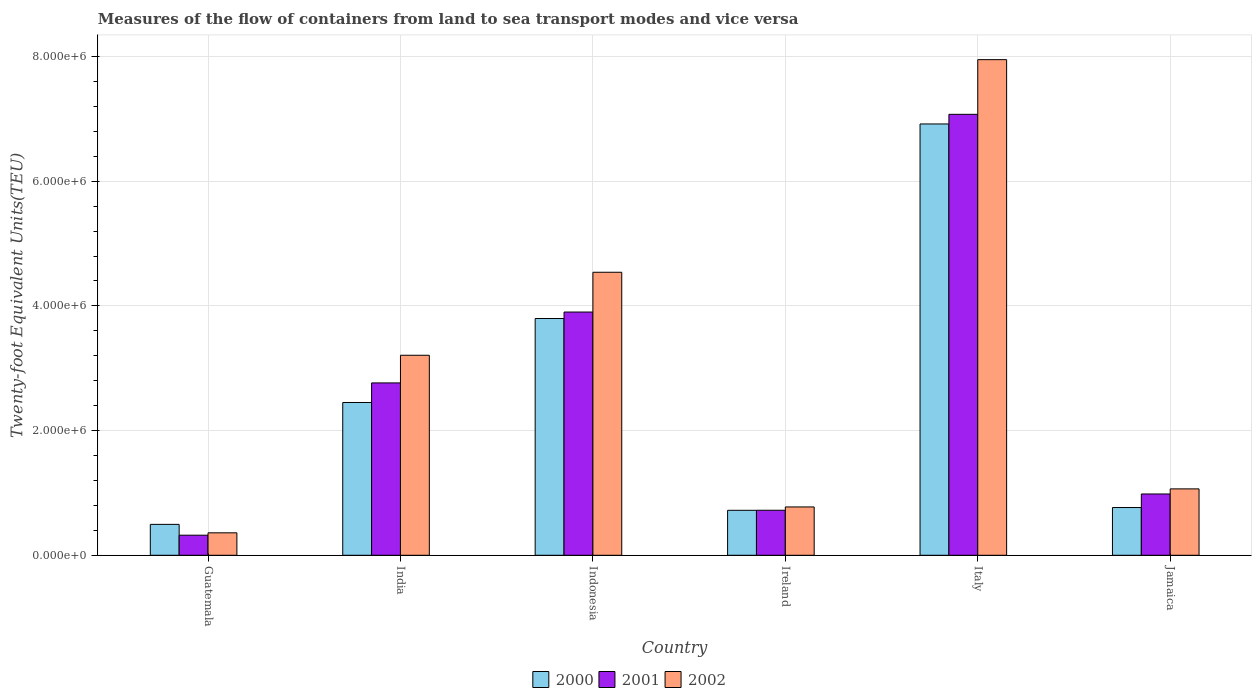Are the number of bars per tick equal to the number of legend labels?
Provide a short and direct response. Yes. Are the number of bars on each tick of the X-axis equal?
Offer a very short reply. Yes. How many bars are there on the 5th tick from the left?
Keep it short and to the point. 3. What is the label of the 3rd group of bars from the left?
Provide a short and direct response. Indonesia. What is the container port traffic in 2000 in Ireland?
Offer a terse response. 7.21e+05. Across all countries, what is the maximum container port traffic in 2001?
Offer a terse response. 7.07e+06. Across all countries, what is the minimum container port traffic in 2001?
Your answer should be very brief. 3.22e+05. In which country was the container port traffic in 2001 minimum?
Provide a short and direct response. Guatemala. What is the total container port traffic in 2001 in the graph?
Your answer should be very brief. 1.58e+07. What is the difference between the container port traffic in 2002 in India and that in Indonesia?
Your answer should be compact. -1.33e+06. What is the difference between the container port traffic in 2000 in Italy and the container port traffic in 2001 in India?
Keep it short and to the point. 4.15e+06. What is the average container port traffic in 2002 per country?
Provide a succinct answer. 2.98e+06. What is the difference between the container port traffic of/in 2001 and container port traffic of/in 2000 in Indonesia?
Your answer should be very brief. 1.04e+05. In how many countries, is the container port traffic in 2000 greater than 6400000 TEU?
Offer a terse response. 1. What is the ratio of the container port traffic in 2002 in Guatemala to that in Indonesia?
Your answer should be very brief. 0.08. What is the difference between the highest and the second highest container port traffic in 2002?
Ensure brevity in your answer.  -3.41e+06. What is the difference between the highest and the lowest container port traffic in 2001?
Provide a succinct answer. 6.75e+06. Is the sum of the container port traffic in 2001 in India and Italy greater than the maximum container port traffic in 2000 across all countries?
Make the answer very short. Yes. What does the 2nd bar from the right in Jamaica represents?
Keep it short and to the point. 2001. Are all the bars in the graph horizontal?
Ensure brevity in your answer.  No. What is the difference between two consecutive major ticks on the Y-axis?
Offer a very short reply. 2.00e+06. Does the graph contain grids?
Provide a short and direct response. Yes. What is the title of the graph?
Offer a terse response. Measures of the flow of containers from land to sea transport modes and vice versa. What is the label or title of the X-axis?
Give a very brief answer. Country. What is the label or title of the Y-axis?
Make the answer very short. Twenty-foot Equivalent Units(TEU). What is the Twenty-foot Equivalent Units(TEU) in 2000 in Guatemala?
Your answer should be compact. 4.96e+05. What is the Twenty-foot Equivalent Units(TEU) of 2001 in Guatemala?
Ensure brevity in your answer.  3.22e+05. What is the Twenty-foot Equivalent Units(TEU) of 2002 in Guatemala?
Provide a succinct answer. 3.60e+05. What is the Twenty-foot Equivalent Units(TEU) of 2000 in India?
Ensure brevity in your answer.  2.45e+06. What is the Twenty-foot Equivalent Units(TEU) of 2001 in India?
Ensure brevity in your answer.  2.76e+06. What is the Twenty-foot Equivalent Units(TEU) in 2002 in India?
Offer a terse response. 3.21e+06. What is the Twenty-foot Equivalent Units(TEU) in 2000 in Indonesia?
Ensure brevity in your answer.  3.80e+06. What is the Twenty-foot Equivalent Units(TEU) in 2001 in Indonesia?
Keep it short and to the point. 3.90e+06. What is the Twenty-foot Equivalent Units(TEU) in 2002 in Indonesia?
Provide a succinct answer. 4.54e+06. What is the Twenty-foot Equivalent Units(TEU) in 2000 in Ireland?
Your answer should be compact. 7.21e+05. What is the Twenty-foot Equivalent Units(TEU) of 2001 in Ireland?
Your answer should be very brief. 7.22e+05. What is the Twenty-foot Equivalent Units(TEU) of 2002 in Ireland?
Offer a terse response. 7.75e+05. What is the Twenty-foot Equivalent Units(TEU) in 2000 in Italy?
Offer a very short reply. 6.92e+06. What is the Twenty-foot Equivalent Units(TEU) in 2001 in Italy?
Offer a terse response. 7.07e+06. What is the Twenty-foot Equivalent Units(TEU) in 2002 in Italy?
Keep it short and to the point. 7.95e+06. What is the Twenty-foot Equivalent Units(TEU) of 2000 in Jamaica?
Ensure brevity in your answer.  7.66e+05. What is the Twenty-foot Equivalent Units(TEU) of 2001 in Jamaica?
Your answer should be compact. 9.83e+05. What is the Twenty-foot Equivalent Units(TEU) of 2002 in Jamaica?
Keep it short and to the point. 1.06e+06. Across all countries, what is the maximum Twenty-foot Equivalent Units(TEU) in 2000?
Keep it short and to the point. 6.92e+06. Across all countries, what is the maximum Twenty-foot Equivalent Units(TEU) in 2001?
Offer a very short reply. 7.07e+06. Across all countries, what is the maximum Twenty-foot Equivalent Units(TEU) of 2002?
Ensure brevity in your answer.  7.95e+06. Across all countries, what is the minimum Twenty-foot Equivalent Units(TEU) of 2000?
Your answer should be very brief. 4.96e+05. Across all countries, what is the minimum Twenty-foot Equivalent Units(TEU) in 2001?
Offer a terse response. 3.22e+05. Across all countries, what is the minimum Twenty-foot Equivalent Units(TEU) in 2002?
Your response must be concise. 3.60e+05. What is the total Twenty-foot Equivalent Units(TEU) of 2000 in the graph?
Provide a succinct answer. 1.52e+07. What is the total Twenty-foot Equivalent Units(TEU) in 2001 in the graph?
Keep it short and to the point. 1.58e+07. What is the total Twenty-foot Equivalent Units(TEU) in 2002 in the graph?
Provide a succinct answer. 1.79e+07. What is the difference between the Twenty-foot Equivalent Units(TEU) of 2000 in Guatemala and that in India?
Give a very brief answer. -1.95e+06. What is the difference between the Twenty-foot Equivalent Units(TEU) of 2001 in Guatemala and that in India?
Make the answer very short. -2.44e+06. What is the difference between the Twenty-foot Equivalent Units(TEU) of 2002 in Guatemala and that in India?
Make the answer very short. -2.85e+06. What is the difference between the Twenty-foot Equivalent Units(TEU) in 2000 in Guatemala and that in Indonesia?
Keep it short and to the point. -3.30e+06. What is the difference between the Twenty-foot Equivalent Units(TEU) in 2001 in Guatemala and that in Indonesia?
Ensure brevity in your answer.  -3.58e+06. What is the difference between the Twenty-foot Equivalent Units(TEU) in 2002 in Guatemala and that in Indonesia?
Make the answer very short. -4.18e+06. What is the difference between the Twenty-foot Equivalent Units(TEU) of 2000 in Guatemala and that in Ireland?
Provide a succinct answer. -2.26e+05. What is the difference between the Twenty-foot Equivalent Units(TEU) of 2001 in Guatemala and that in Ireland?
Your response must be concise. -4.00e+05. What is the difference between the Twenty-foot Equivalent Units(TEU) of 2002 in Guatemala and that in Ireland?
Give a very brief answer. -4.15e+05. What is the difference between the Twenty-foot Equivalent Units(TEU) in 2000 in Guatemala and that in Italy?
Give a very brief answer. -6.42e+06. What is the difference between the Twenty-foot Equivalent Units(TEU) of 2001 in Guatemala and that in Italy?
Ensure brevity in your answer.  -6.75e+06. What is the difference between the Twenty-foot Equivalent Units(TEU) of 2002 in Guatemala and that in Italy?
Your answer should be very brief. -7.59e+06. What is the difference between the Twenty-foot Equivalent Units(TEU) of 2000 in Guatemala and that in Jamaica?
Provide a short and direct response. -2.70e+05. What is the difference between the Twenty-foot Equivalent Units(TEU) of 2001 in Guatemala and that in Jamaica?
Make the answer very short. -6.61e+05. What is the difference between the Twenty-foot Equivalent Units(TEU) of 2002 in Guatemala and that in Jamaica?
Offer a terse response. -7.05e+05. What is the difference between the Twenty-foot Equivalent Units(TEU) in 2000 in India and that in Indonesia?
Provide a succinct answer. -1.35e+06. What is the difference between the Twenty-foot Equivalent Units(TEU) of 2001 in India and that in Indonesia?
Your answer should be very brief. -1.14e+06. What is the difference between the Twenty-foot Equivalent Units(TEU) in 2002 in India and that in Indonesia?
Give a very brief answer. -1.33e+06. What is the difference between the Twenty-foot Equivalent Units(TEU) of 2000 in India and that in Ireland?
Ensure brevity in your answer.  1.73e+06. What is the difference between the Twenty-foot Equivalent Units(TEU) of 2001 in India and that in Ireland?
Ensure brevity in your answer.  2.04e+06. What is the difference between the Twenty-foot Equivalent Units(TEU) in 2002 in India and that in Ireland?
Your answer should be very brief. 2.43e+06. What is the difference between the Twenty-foot Equivalent Units(TEU) in 2000 in India and that in Italy?
Your response must be concise. -4.47e+06. What is the difference between the Twenty-foot Equivalent Units(TEU) in 2001 in India and that in Italy?
Offer a terse response. -4.31e+06. What is the difference between the Twenty-foot Equivalent Units(TEU) of 2002 in India and that in Italy?
Offer a very short reply. -4.74e+06. What is the difference between the Twenty-foot Equivalent Units(TEU) in 2000 in India and that in Jamaica?
Your answer should be compact. 1.68e+06. What is the difference between the Twenty-foot Equivalent Units(TEU) of 2001 in India and that in Jamaica?
Your answer should be very brief. 1.78e+06. What is the difference between the Twenty-foot Equivalent Units(TEU) of 2002 in India and that in Jamaica?
Offer a terse response. 2.14e+06. What is the difference between the Twenty-foot Equivalent Units(TEU) in 2000 in Indonesia and that in Ireland?
Your answer should be very brief. 3.08e+06. What is the difference between the Twenty-foot Equivalent Units(TEU) in 2001 in Indonesia and that in Ireland?
Keep it short and to the point. 3.18e+06. What is the difference between the Twenty-foot Equivalent Units(TEU) in 2002 in Indonesia and that in Ireland?
Offer a terse response. 3.76e+06. What is the difference between the Twenty-foot Equivalent Units(TEU) in 2000 in Indonesia and that in Italy?
Provide a succinct answer. -3.12e+06. What is the difference between the Twenty-foot Equivalent Units(TEU) in 2001 in Indonesia and that in Italy?
Offer a terse response. -3.17e+06. What is the difference between the Twenty-foot Equivalent Units(TEU) of 2002 in Indonesia and that in Italy?
Your answer should be compact. -3.41e+06. What is the difference between the Twenty-foot Equivalent Units(TEU) of 2000 in Indonesia and that in Jamaica?
Your answer should be compact. 3.03e+06. What is the difference between the Twenty-foot Equivalent Units(TEU) in 2001 in Indonesia and that in Jamaica?
Make the answer very short. 2.92e+06. What is the difference between the Twenty-foot Equivalent Units(TEU) in 2002 in Indonesia and that in Jamaica?
Your answer should be very brief. 3.47e+06. What is the difference between the Twenty-foot Equivalent Units(TEU) of 2000 in Ireland and that in Italy?
Provide a succinct answer. -6.20e+06. What is the difference between the Twenty-foot Equivalent Units(TEU) in 2001 in Ireland and that in Italy?
Give a very brief answer. -6.35e+06. What is the difference between the Twenty-foot Equivalent Units(TEU) of 2002 in Ireland and that in Italy?
Your response must be concise. -7.17e+06. What is the difference between the Twenty-foot Equivalent Units(TEU) in 2000 in Ireland and that in Jamaica?
Provide a short and direct response. -4.46e+04. What is the difference between the Twenty-foot Equivalent Units(TEU) of 2001 in Ireland and that in Jamaica?
Your response must be concise. -2.61e+05. What is the difference between the Twenty-foot Equivalent Units(TEU) of 2002 in Ireland and that in Jamaica?
Give a very brief answer. -2.90e+05. What is the difference between the Twenty-foot Equivalent Units(TEU) of 2000 in Italy and that in Jamaica?
Offer a terse response. 6.15e+06. What is the difference between the Twenty-foot Equivalent Units(TEU) in 2001 in Italy and that in Jamaica?
Your answer should be compact. 6.09e+06. What is the difference between the Twenty-foot Equivalent Units(TEU) in 2002 in Italy and that in Jamaica?
Give a very brief answer. 6.89e+06. What is the difference between the Twenty-foot Equivalent Units(TEU) of 2000 in Guatemala and the Twenty-foot Equivalent Units(TEU) of 2001 in India?
Provide a succinct answer. -2.27e+06. What is the difference between the Twenty-foot Equivalent Units(TEU) in 2000 in Guatemala and the Twenty-foot Equivalent Units(TEU) in 2002 in India?
Provide a succinct answer. -2.71e+06. What is the difference between the Twenty-foot Equivalent Units(TEU) in 2001 in Guatemala and the Twenty-foot Equivalent Units(TEU) in 2002 in India?
Keep it short and to the point. -2.89e+06. What is the difference between the Twenty-foot Equivalent Units(TEU) of 2000 in Guatemala and the Twenty-foot Equivalent Units(TEU) of 2001 in Indonesia?
Keep it short and to the point. -3.41e+06. What is the difference between the Twenty-foot Equivalent Units(TEU) of 2000 in Guatemala and the Twenty-foot Equivalent Units(TEU) of 2002 in Indonesia?
Provide a succinct answer. -4.04e+06. What is the difference between the Twenty-foot Equivalent Units(TEU) of 2001 in Guatemala and the Twenty-foot Equivalent Units(TEU) of 2002 in Indonesia?
Ensure brevity in your answer.  -4.22e+06. What is the difference between the Twenty-foot Equivalent Units(TEU) in 2000 in Guatemala and the Twenty-foot Equivalent Units(TEU) in 2001 in Ireland?
Provide a succinct answer. -2.26e+05. What is the difference between the Twenty-foot Equivalent Units(TEU) in 2000 in Guatemala and the Twenty-foot Equivalent Units(TEU) in 2002 in Ireland?
Your response must be concise. -2.80e+05. What is the difference between the Twenty-foot Equivalent Units(TEU) of 2001 in Guatemala and the Twenty-foot Equivalent Units(TEU) of 2002 in Ireland?
Give a very brief answer. -4.53e+05. What is the difference between the Twenty-foot Equivalent Units(TEU) of 2000 in Guatemala and the Twenty-foot Equivalent Units(TEU) of 2001 in Italy?
Offer a very short reply. -6.58e+06. What is the difference between the Twenty-foot Equivalent Units(TEU) in 2000 in Guatemala and the Twenty-foot Equivalent Units(TEU) in 2002 in Italy?
Offer a terse response. -7.45e+06. What is the difference between the Twenty-foot Equivalent Units(TEU) in 2001 in Guatemala and the Twenty-foot Equivalent Units(TEU) in 2002 in Italy?
Your answer should be very brief. -7.63e+06. What is the difference between the Twenty-foot Equivalent Units(TEU) in 2000 in Guatemala and the Twenty-foot Equivalent Units(TEU) in 2001 in Jamaica?
Ensure brevity in your answer.  -4.88e+05. What is the difference between the Twenty-foot Equivalent Units(TEU) in 2000 in Guatemala and the Twenty-foot Equivalent Units(TEU) in 2002 in Jamaica?
Offer a terse response. -5.69e+05. What is the difference between the Twenty-foot Equivalent Units(TEU) in 2001 in Guatemala and the Twenty-foot Equivalent Units(TEU) in 2002 in Jamaica?
Provide a short and direct response. -7.43e+05. What is the difference between the Twenty-foot Equivalent Units(TEU) in 2000 in India and the Twenty-foot Equivalent Units(TEU) in 2001 in Indonesia?
Keep it short and to the point. -1.45e+06. What is the difference between the Twenty-foot Equivalent Units(TEU) of 2000 in India and the Twenty-foot Equivalent Units(TEU) of 2002 in Indonesia?
Ensure brevity in your answer.  -2.09e+06. What is the difference between the Twenty-foot Equivalent Units(TEU) in 2001 in India and the Twenty-foot Equivalent Units(TEU) in 2002 in Indonesia?
Keep it short and to the point. -1.78e+06. What is the difference between the Twenty-foot Equivalent Units(TEU) of 2000 in India and the Twenty-foot Equivalent Units(TEU) of 2001 in Ireland?
Offer a terse response. 1.73e+06. What is the difference between the Twenty-foot Equivalent Units(TEU) of 2000 in India and the Twenty-foot Equivalent Units(TEU) of 2002 in Ireland?
Give a very brief answer. 1.68e+06. What is the difference between the Twenty-foot Equivalent Units(TEU) of 2001 in India and the Twenty-foot Equivalent Units(TEU) of 2002 in Ireland?
Keep it short and to the point. 1.99e+06. What is the difference between the Twenty-foot Equivalent Units(TEU) in 2000 in India and the Twenty-foot Equivalent Units(TEU) in 2001 in Italy?
Ensure brevity in your answer.  -4.62e+06. What is the difference between the Twenty-foot Equivalent Units(TEU) of 2000 in India and the Twenty-foot Equivalent Units(TEU) of 2002 in Italy?
Make the answer very short. -5.50e+06. What is the difference between the Twenty-foot Equivalent Units(TEU) of 2001 in India and the Twenty-foot Equivalent Units(TEU) of 2002 in Italy?
Ensure brevity in your answer.  -5.19e+06. What is the difference between the Twenty-foot Equivalent Units(TEU) of 2000 in India and the Twenty-foot Equivalent Units(TEU) of 2001 in Jamaica?
Ensure brevity in your answer.  1.47e+06. What is the difference between the Twenty-foot Equivalent Units(TEU) of 2000 in India and the Twenty-foot Equivalent Units(TEU) of 2002 in Jamaica?
Provide a succinct answer. 1.39e+06. What is the difference between the Twenty-foot Equivalent Units(TEU) of 2001 in India and the Twenty-foot Equivalent Units(TEU) of 2002 in Jamaica?
Give a very brief answer. 1.70e+06. What is the difference between the Twenty-foot Equivalent Units(TEU) in 2000 in Indonesia and the Twenty-foot Equivalent Units(TEU) in 2001 in Ireland?
Keep it short and to the point. 3.08e+06. What is the difference between the Twenty-foot Equivalent Units(TEU) in 2000 in Indonesia and the Twenty-foot Equivalent Units(TEU) in 2002 in Ireland?
Provide a succinct answer. 3.02e+06. What is the difference between the Twenty-foot Equivalent Units(TEU) of 2001 in Indonesia and the Twenty-foot Equivalent Units(TEU) of 2002 in Ireland?
Your answer should be very brief. 3.13e+06. What is the difference between the Twenty-foot Equivalent Units(TEU) in 2000 in Indonesia and the Twenty-foot Equivalent Units(TEU) in 2001 in Italy?
Provide a succinct answer. -3.28e+06. What is the difference between the Twenty-foot Equivalent Units(TEU) in 2000 in Indonesia and the Twenty-foot Equivalent Units(TEU) in 2002 in Italy?
Offer a terse response. -4.15e+06. What is the difference between the Twenty-foot Equivalent Units(TEU) of 2001 in Indonesia and the Twenty-foot Equivalent Units(TEU) of 2002 in Italy?
Give a very brief answer. -4.05e+06. What is the difference between the Twenty-foot Equivalent Units(TEU) of 2000 in Indonesia and the Twenty-foot Equivalent Units(TEU) of 2001 in Jamaica?
Offer a very short reply. 2.81e+06. What is the difference between the Twenty-foot Equivalent Units(TEU) in 2000 in Indonesia and the Twenty-foot Equivalent Units(TEU) in 2002 in Jamaica?
Your answer should be compact. 2.73e+06. What is the difference between the Twenty-foot Equivalent Units(TEU) in 2001 in Indonesia and the Twenty-foot Equivalent Units(TEU) in 2002 in Jamaica?
Offer a terse response. 2.84e+06. What is the difference between the Twenty-foot Equivalent Units(TEU) of 2000 in Ireland and the Twenty-foot Equivalent Units(TEU) of 2001 in Italy?
Offer a terse response. -6.35e+06. What is the difference between the Twenty-foot Equivalent Units(TEU) in 2000 in Ireland and the Twenty-foot Equivalent Units(TEU) in 2002 in Italy?
Your answer should be very brief. -7.23e+06. What is the difference between the Twenty-foot Equivalent Units(TEU) of 2001 in Ireland and the Twenty-foot Equivalent Units(TEU) of 2002 in Italy?
Your answer should be compact. -7.23e+06. What is the difference between the Twenty-foot Equivalent Units(TEU) in 2000 in Ireland and the Twenty-foot Equivalent Units(TEU) in 2001 in Jamaica?
Make the answer very short. -2.62e+05. What is the difference between the Twenty-foot Equivalent Units(TEU) of 2000 in Ireland and the Twenty-foot Equivalent Units(TEU) of 2002 in Jamaica?
Your answer should be compact. -3.44e+05. What is the difference between the Twenty-foot Equivalent Units(TEU) of 2001 in Ireland and the Twenty-foot Equivalent Units(TEU) of 2002 in Jamaica?
Keep it short and to the point. -3.43e+05. What is the difference between the Twenty-foot Equivalent Units(TEU) of 2000 in Italy and the Twenty-foot Equivalent Units(TEU) of 2001 in Jamaica?
Your answer should be compact. 5.94e+06. What is the difference between the Twenty-foot Equivalent Units(TEU) of 2000 in Italy and the Twenty-foot Equivalent Units(TEU) of 2002 in Jamaica?
Provide a succinct answer. 5.85e+06. What is the difference between the Twenty-foot Equivalent Units(TEU) in 2001 in Italy and the Twenty-foot Equivalent Units(TEU) in 2002 in Jamaica?
Make the answer very short. 6.01e+06. What is the average Twenty-foot Equivalent Units(TEU) in 2000 per country?
Your answer should be very brief. 2.53e+06. What is the average Twenty-foot Equivalent Units(TEU) in 2001 per country?
Give a very brief answer. 2.63e+06. What is the average Twenty-foot Equivalent Units(TEU) in 2002 per country?
Offer a terse response. 2.98e+06. What is the difference between the Twenty-foot Equivalent Units(TEU) in 2000 and Twenty-foot Equivalent Units(TEU) in 2001 in Guatemala?
Your answer should be very brief. 1.74e+05. What is the difference between the Twenty-foot Equivalent Units(TEU) of 2000 and Twenty-foot Equivalent Units(TEU) of 2002 in Guatemala?
Provide a succinct answer. 1.36e+05. What is the difference between the Twenty-foot Equivalent Units(TEU) in 2001 and Twenty-foot Equivalent Units(TEU) in 2002 in Guatemala?
Your answer should be compact. -3.80e+04. What is the difference between the Twenty-foot Equivalent Units(TEU) of 2000 and Twenty-foot Equivalent Units(TEU) of 2001 in India?
Your response must be concise. -3.14e+05. What is the difference between the Twenty-foot Equivalent Units(TEU) in 2000 and Twenty-foot Equivalent Units(TEU) in 2002 in India?
Ensure brevity in your answer.  -7.58e+05. What is the difference between the Twenty-foot Equivalent Units(TEU) in 2001 and Twenty-foot Equivalent Units(TEU) in 2002 in India?
Offer a very short reply. -4.44e+05. What is the difference between the Twenty-foot Equivalent Units(TEU) of 2000 and Twenty-foot Equivalent Units(TEU) of 2001 in Indonesia?
Offer a terse response. -1.04e+05. What is the difference between the Twenty-foot Equivalent Units(TEU) in 2000 and Twenty-foot Equivalent Units(TEU) in 2002 in Indonesia?
Offer a very short reply. -7.42e+05. What is the difference between the Twenty-foot Equivalent Units(TEU) of 2001 and Twenty-foot Equivalent Units(TEU) of 2002 in Indonesia?
Provide a succinct answer. -6.38e+05. What is the difference between the Twenty-foot Equivalent Units(TEU) of 2000 and Twenty-foot Equivalent Units(TEU) of 2001 in Ireland?
Provide a short and direct response. -753. What is the difference between the Twenty-foot Equivalent Units(TEU) of 2000 and Twenty-foot Equivalent Units(TEU) of 2002 in Ireland?
Your answer should be compact. -5.39e+04. What is the difference between the Twenty-foot Equivalent Units(TEU) of 2001 and Twenty-foot Equivalent Units(TEU) of 2002 in Ireland?
Provide a short and direct response. -5.32e+04. What is the difference between the Twenty-foot Equivalent Units(TEU) in 2000 and Twenty-foot Equivalent Units(TEU) in 2001 in Italy?
Give a very brief answer. -1.55e+05. What is the difference between the Twenty-foot Equivalent Units(TEU) in 2000 and Twenty-foot Equivalent Units(TEU) in 2002 in Italy?
Provide a short and direct response. -1.03e+06. What is the difference between the Twenty-foot Equivalent Units(TEU) of 2001 and Twenty-foot Equivalent Units(TEU) of 2002 in Italy?
Provide a short and direct response. -8.77e+05. What is the difference between the Twenty-foot Equivalent Units(TEU) of 2000 and Twenty-foot Equivalent Units(TEU) of 2001 in Jamaica?
Ensure brevity in your answer.  -2.17e+05. What is the difference between the Twenty-foot Equivalent Units(TEU) of 2000 and Twenty-foot Equivalent Units(TEU) of 2002 in Jamaica?
Make the answer very short. -2.99e+05. What is the difference between the Twenty-foot Equivalent Units(TEU) in 2001 and Twenty-foot Equivalent Units(TEU) in 2002 in Jamaica?
Provide a short and direct response. -8.16e+04. What is the ratio of the Twenty-foot Equivalent Units(TEU) in 2000 in Guatemala to that in India?
Offer a very short reply. 0.2. What is the ratio of the Twenty-foot Equivalent Units(TEU) of 2001 in Guatemala to that in India?
Offer a terse response. 0.12. What is the ratio of the Twenty-foot Equivalent Units(TEU) of 2002 in Guatemala to that in India?
Make the answer very short. 0.11. What is the ratio of the Twenty-foot Equivalent Units(TEU) of 2000 in Guatemala to that in Indonesia?
Ensure brevity in your answer.  0.13. What is the ratio of the Twenty-foot Equivalent Units(TEU) of 2001 in Guatemala to that in Indonesia?
Make the answer very short. 0.08. What is the ratio of the Twenty-foot Equivalent Units(TEU) in 2002 in Guatemala to that in Indonesia?
Provide a short and direct response. 0.08. What is the ratio of the Twenty-foot Equivalent Units(TEU) of 2000 in Guatemala to that in Ireland?
Make the answer very short. 0.69. What is the ratio of the Twenty-foot Equivalent Units(TEU) in 2001 in Guatemala to that in Ireland?
Provide a succinct answer. 0.45. What is the ratio of the Twenty-foot Equivalent Units(TEU) of 2002 in Guatemala to that in Ireland?
Offer a terse response. 0.46. What is the ratio of the Twenty-foot Equivalent Units(TEU) in 2000 in Guatemala to that in Italy?
Your answer should be very brief. 0.07. What is the ratio of the Twenty-foot Equivalent Units(TEU) in 2001 in Guatemala to that in Italy?
Make the answer very short. 0.05. What is the ratio of the Twenty-foot Equivalent Units(TEU) of 2002 in Guatemala to that in Italy?
Give a very brief answer. 0.05. What is the ratio of the Twenty-foot Equivalent Units(TEU) in 2000 in Guatemala to that in Jamaica?
Offer a terse response. 0.65. What is the ratio of the Twenty-foot Equivalent Units(TEU) of 2001 in Guatemala to that in Jamaica?
Make the answer very short. 0.33. What is the ratio of the Twenty-foot Equivalent Units(TEU) of 2002 in Guatemala to that in Jamaica?
Your response must be concise. 0.34. What is the ratio of the Twenty-foot Equivalent Units(TEU) in 2000 in India to that in Indonesia?
Give a very brief answer. 0.65. What is the ratio of the Twenty-foot Equivalent Units(TEU) in 2001 in India to that in Indonesia?
Offer a terse response. 0.71. What is the ratio of the Twenty-foot Equivalent Units(TEU) in 2002 in India to that in Indonesia?
Ensure brevity in your answer.  0.71. What is the ratio of the Twenty-foot Equivalent Units(TEU) in 2000 in India to that in Ireland?
Ensure brevity in your answer.  3.4. What is the ratio of the Twenty-foot Equivalent Units(TEU) of 2001 in India to that in Ireland?
Offer a very short reply. 3.83. What is the ratio of the Twenty-foot Equivalent Units(TEU) in 2002 in India to that in Ireland?
Offer a very short reply. 4.14. What is the ratio of the Twenty-foot Equivalent Units(TEU) of 2000 in India to that in Italy?
Your response must be concise. 0.35. What is the ratio of the Twenty-foot Equivalent Units(TEU) in 2001 in India to that in Italy?
Keep it short and to the point. 0.39. What is the ratio of the Twenty-foot Equivalent Units(TEU) in 2002 in India to that in Italy?
Keep it short and to the point. 0.4. What is the ratio of the Twenty-foot Equivalent Units(TEU) of 2000 in India to that in Jamaica?
Make the answer very short. 3.2. What is the ratio of the Twenty-foot Equivalent Units(TEU) in 2001 in India to that in Jamaica?
Give a very brief answer. 2.81. What is the ratio of the Twenty-foot Equivalent Units(TEU) of 2002 in India to that in Jamaica?
Your answer should be very brief. 3.01. What is the ratio of the Twenty-foot Equivalent Units(TEU) in 2000 in Indonesia to that in Ireland?
Provide a short and direct response. 5.26. What is the ratio of the Twenty-foot Equivalent Units(TEU) in 2001 in Indonesia to that in Ireland?
Ensure brevity in your answer.  5.4. What is the ratio of the Twenty-foot Equivalent Units(TEU) of 2002 in Indonesia to that in Ireland?
Offer a very short reply. 5.86. What is the ratio of the Twenty-foot Equivalent Units(TEU) in 2000 in Indonesia to that in Italy?
Provide a short and direct response. 0.55. What is the ratio of the Twenty-foot Equivalent Units(TEU) of 2001 in Indonesia to that in Italy?
Provide a succinct answer. 0.55. What is the ratio of the Twenty-foot Equivalent Units(TEU) of 2002 in Indonesia to that in Italy?
Your response must be concise. 0.57. What is the ratio of the Twenty-foot Equivalent Units(TEU) of 2000 in Indonesia to that in Jamaica?
Keep it short and to the point. 4.96. What is the ratio of the Twenty-foot Equivalent Units(TEU) in 2001 in Indonesia to that in Jamaica?
Your answer should be very brief. 3.97. What is the ratio of the Twenty-foot Equivalent Units(TEU) of 2002 in Indonesia to that in Jamaica?
Provide a succinct answer. 4.26. What is the ratio of the Twenty-foot Equivalent Units(TEU) of 2000 in Ireland to that in Italy?
Your answer should be very brief. 0.1. What is the ratio of the Twenty-foot Equivalent Units(TEU) in 2001 in Ireland to that in Italy?
Give a very brief answer. 0.1. What is the ratio of the Twenty-foot Equivalent Units(TEU) of 2002 in Ireland to that in Italy?
Offer a very short reply. 0.1. What is the ratio of the Twenty-foot Equivalent Units(TEU) of 2000 in Ireland to that in Jamaica?
Your answer should be very brief. 0.94. What is the ratio of the Twenty-foot Equivalent Units(TEU) of 2001 in Ireland to that in Jamaica?
Keep it short and to the point. 0.73. What is the ratio of the Twenty-foot Equivalent Units(TEU) in 2002 in Ireland to that in Jamaica?
Offer a terse response. 0.73. What is the ratio of the Twenty-foot Equivalent Units(TEU) in 2000 in Italy to that in Jamaica?
Your response must be concise. 9.03. What is the ratio of the Twenty-foot Equivalent Units(TEU) of 2001 in Italy to that in Jamaica?
Your answer should be very brief. 7.19. What is the ratio of the Twenty-foot Equivalent Units(TEU) in 2002 in Italy to that in Jamaica?
Provide a succinct answer. 7.46. What is the difference between the highest and the second highest Twenty-foot Equivalent Units(TEU) in 2000?
Keep it short and to the point. 3.12e+06. What is the difference between the highest and the second highest Twenty-foot Equivalent Units(TEU) of 2001?
Your answer should be very brief. 3.17e+06. What is the difference between the highest and the second highest Twenty-foot Equivalent Units(TEU) in 2002?
Your answer should be compact. 3.41e+06. What is the difference between the highest and the lowest Twenty-foot Equivalent Units(TEU) in 2000?
Give a very brief answer. 6.42e+06. What is the difference between the highest and the lowest Twenty-foot Equivalent Units(TEU) of 2001?
Offer a terse response. 6.75e+06. What is the difference between the highest and the lowest Twenty-foot Equivalent Units(TEU) in 2002?
Make the answer very short. 7.59e+06. 